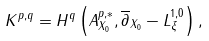Convert formula to latex. <formula><loc_0><loc_0><loc_500><loc_500>K ^ { p , q } = H ^ { q } \left ( A _ { X _ { 0 } } ^ { p , * } , \overline { \partial } _ { X _ { 0 } } - L _ { \xi } ^ { 1 , 0 } \right ) ,</formula> 